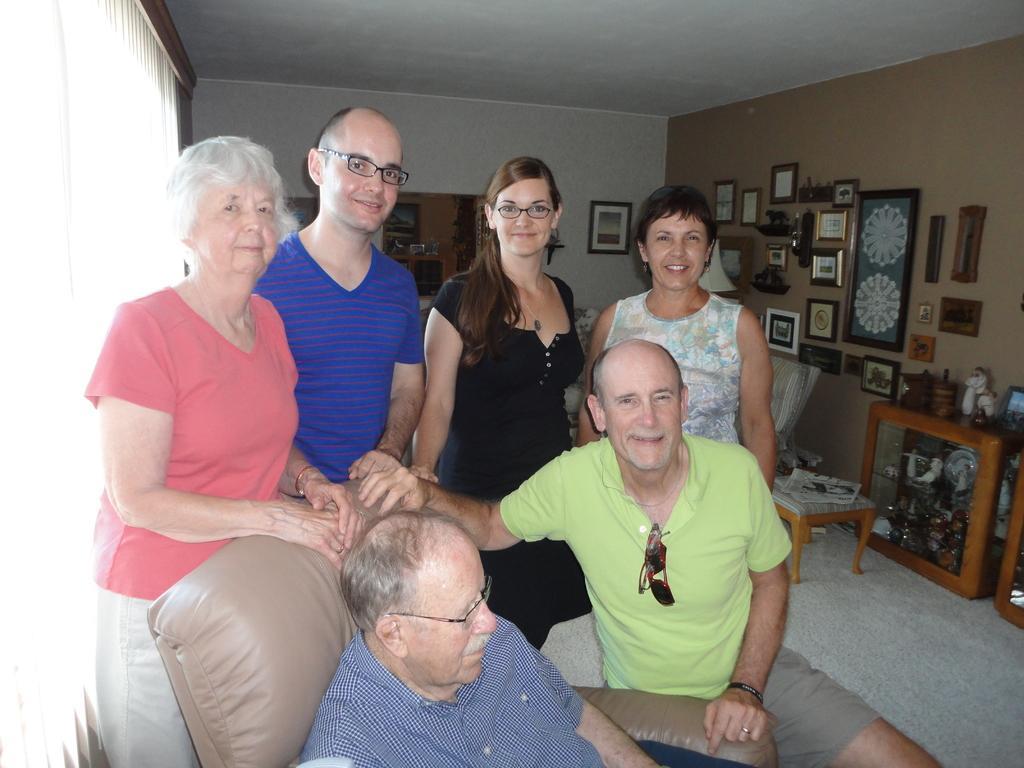In one or two sentences, can you explain what this image depicts? In this image there are two people sitting in chairs, behind them there are a few people standing with a smile on their face are posing for the camera, behind them there are chairs, tables, photo frames on the wall and a few other objects, in the background of the image there is curtain on the wall. 